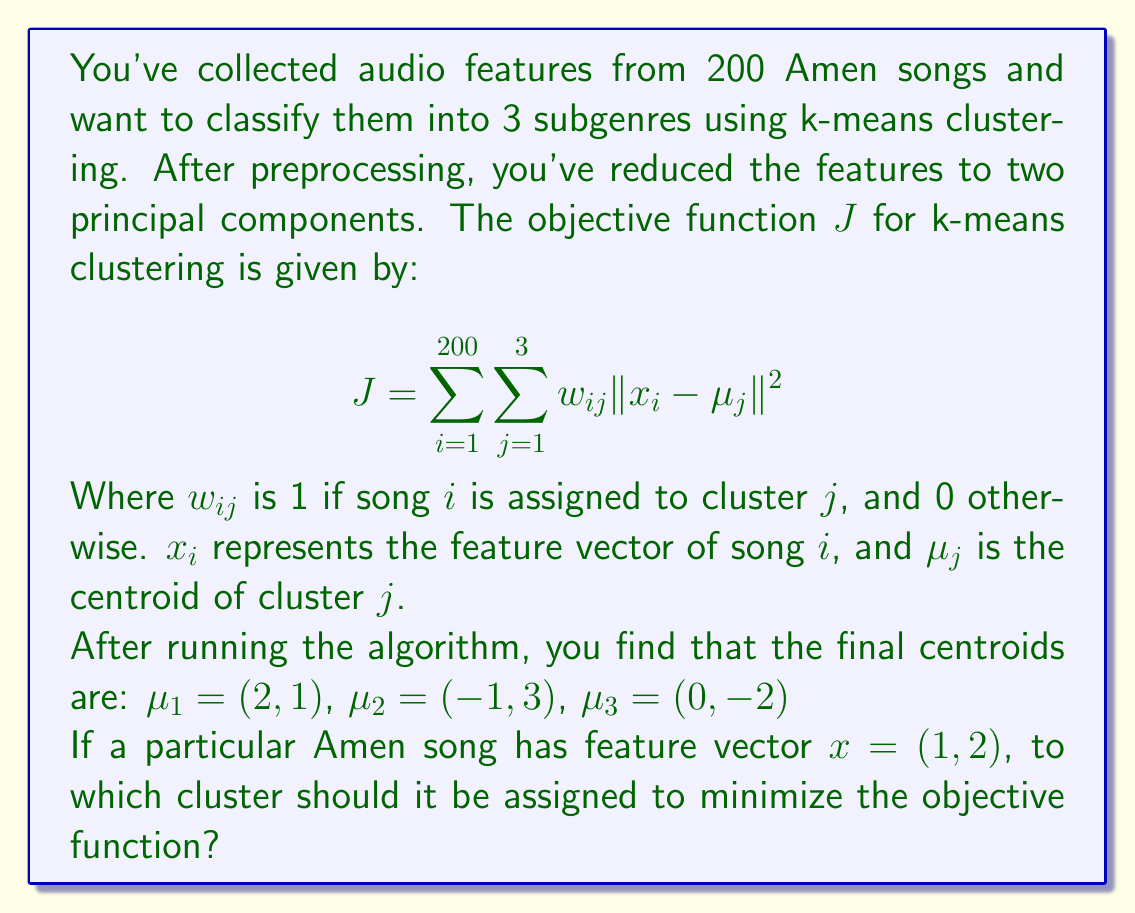Teach me how to tackle this problem. To solve this problem, we need to follow these steps:

1) The k-means algorithm assigns each point to the nearest centroid to minimize the objective function. Therefore, we need to calculate the Euclidean distance between the song's feature vector and each centroid.

2) The Euclidean distance between two points $(x_1, y_1)$ and $(x_2, y_2)$ is given by:

   $$d = \sqrt{(x_2 - x_1)^2 + (y_2 - y_1)^2}$$

3) Let's calculate the distance to each centroid:

   For $\mu_1 = (2, 1)$:
   $$d_1 = \sqrt{(2 - 1)^2 + (1 - 2)^2} = \sqrt{1^2 + (-1)^2} = \sqrt{2}$$

   For $\mu_2 = (-1, 3)$:
   $$d_2 = \sqrt{(-1 - 1)^2 + (3 - 2)^2} = \sqrt{(-2)^2 + 1^2} = \sqrt{5}$$

   For $\mu_3 = (0, -2)$:
   $$d_3 = \sqrt{(0 - 1)^2 + (-2 - 2)^2} = \sqrt{(-1)^2 + (-4)^2} = \sqrt{17}$$

4) The song should be assigned to the cluster with the smallest distance to minimize the objective function.

5) Comparing the distances:
   $\sqrt{2} < \sqrt{5} < \sqrt{17}$

Therefore, the smallest distance is to $\mu_1$.
Answer: The Amen song with feature vector $x = (1, 2)$ should be assigned to cluster 1, corresponding to centroid $\mu_1 = (2, 1)$, to minimize the objective function. 